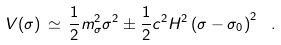Convert formula to latex. <formula><loc_0><loc_0><loc_500><loc_500>V ( \sigma ) \, \simeq \, \frac { 1 } { 2 } m _ { \sigma } ^ { 2 } \sigma ^ { 2 } \pm \frac { 1 } { 2 } c ^ { 2 } H ^ { 2 } \left ( \sigma - \sigma _ { 0 } \right ) ^ { 2 } \ .</formula> 